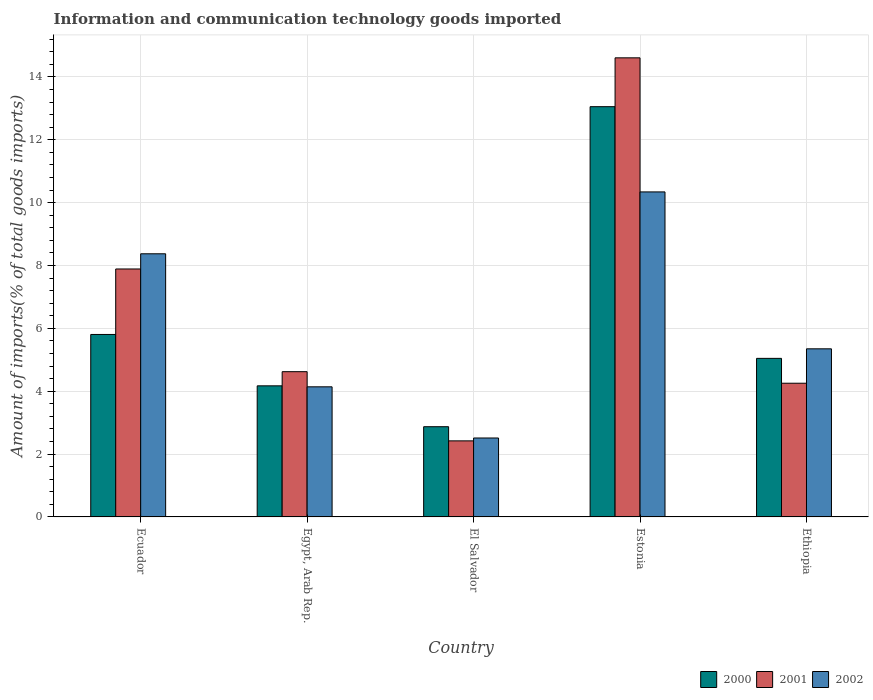How many different coloured bars are there?
Your response must be concise. 3. Are the number of bars on each tick of the X-axis equal?
Offer a very short reply. Yes. How many bars are there on the 5th tick from the left?
Your answer should be very brief. 3. How many bars are there on the 4th tick from the right?
Keep it short and to the point. 3. What is the label of the 1st group of bars from the left?
Your answer should be compact. Ecuador. In how many cases, is the number of bars for a given country not equal to the number of legend labels?
Your answer should be very brief. 0. What is the amount of goods imported in 2002 in Ethiopia?
Offer a terse response. 5.35. Across all countries, what is the maximum amount of goods imported in 2002?
Give a very brief answer. 10.34. Across all countries, what is the minimum amount of goods imported in 2001?
Offer a very short reply. 2.42. In which country was the amount of goods imported in 2000 maximum?
Offer a terse response. Estonia. In which country was the amount of goods imported in 2001 minimum?
Your response must be concise. El Salvador. What is the total amount of goods imported in 2001 in the graph?
Give a very brief answer. 33.79. What is the difference between the amount of goods imported in 2002 in Egypt, Arab Rep. and that in Ethiopia?
Your answer should be compact. -1.21. What is the difference between the amount of goods imported in 2002 in El Salvador and the amount of goods imported in 2001 in Egypt, Arab Rep.?
Your answer should be compact. -2.11. What is the average amount of goods imported in 2001 per country?
Your answer should be compact. 6.76. What is the difference between the amount of goods imported of/in 2002 and amount of goods imported of/in 2001 in Egypt, Arab Rep.?
Make the answer very short. -0.48. In how many countries, is the amount of goods imported in 2002 greater than 6.4 %?
Your answer should be compact. 2. What is the ratio of the amount of goods imported in 2000 in Ecuador to that in Egypt, Arab Rep.?
Make the answer very short. 1.39. Is the amount of goods imported in 2002 in Egypt, Arab Rep. less than that in Ethiopia?
Your answer should be compact. Yes. Is the difference between the amount of goods imported in 2002 in Estonia and Ethiopia greater than the difference between the amount of goods imported in 2001 in Estonia and Ethiopia?
Your answer should be very brief. No. What is the difference between the highest and the second highest amount of goods imported in 2001?
Provide a succinct answer. -9.99. What is the difference between the highest and the lowest amount of goods imported in 2001?
Make the answer very short. 12.19. In how many countries, is the amount of goods imported in 2002 greater than the average amount of goods imported in 2002 taken over all countries?
Make the answer very short. 2. What does the 1st bar from the left in Egypt, Arab Rep. represents?
Offer a terse response. 2000. How many bars are there?
Provide a short and direct response. 15. Are all the bars in the graph horizontal?
Provide a short and direct response. No. What is the difference between two consecutive major ticks on the Y-axis?
Provide a short and direct response. 2. Are the values on the major ticks of Y-axis written in scientific E-notation?
Make the answer very short. No. Does the graph contain any zero values?
Keep it short and to the point. No. Does the graph contain grids?
Provide a short and direct response. Yes. How many legend labels are there?
Offer a terse response. 3. How are the legend labels stacked?
Provide a succinct answer. Horizontal. What is the title of the graph?
Give a very brief answer. Information and communication technology goods imported. Does "1990" appear as one of the legend labels in the graph?
Your answer should be very brief. No. What is the label or title of the Y-axis?
Make the answer very short. Amount of imports(% of total goods imports). What is the Amount of imports(% of total goods imports) of 2000 in Ecuador?
Offer a very short reply. 5.81. What is the Amount of imports(% of total goods imports) in 2001 in Ecuador?
Provide a short and direct response. 7.89. What is the Amount of imports(% of total goods imports) of 2002 in Ecuador?
Provide a succinct answer. 8.37. What is the Amount of imports(% of total goods imports) of 2000 in Egypt, Arab Rep.?
Provide a short and direct response. 4.17. What is the Amount of imports(% of total goods imports) of 2001 in Egypt, Arab Rep.?
Make the answer very short. 4.62. What is the Amount of imports(% of total goods imports) in 2002 in Egypt, Arab Rep.?
Your answer should be compact. 4.14. What is the Amount of imports(% of total goods imports) of 2000 in El Salvador?
Make the answer very short. 2.87. What is the Amount of imports(% of total goods imports) of 2001 in El Salvador?
Keep it short and to the point. 2.42. What is the Amount of imports(% of total goods imports) of 2002 in El Salvador?
Offer a terse response. 2.51. What is the Amount of imports(% of total goods imports) in 2000 in Estonia?
Your response must be concise. 13.05. What is the Amount of imports(% of total goods imports) of 2001 in Estonia?
Your response must be concise. 14.61. What is the Amount of imports(% of total goods imports) in 2002 in Estonia?
Offer a terse response. 10.34. What is the Amount of imports(% of total goods imports) in 2000 in Ethiopia?
Your answer should be very brief. 5.05. What is the Amount of imports(% of total goods imports) in 2001 in Ethiopia?
Offer a very short reply. 4.25. What is the Amount of imports(% of total goods imports) in 2002 in Ethiopia?
Make the answer very short. 5.35. Across all countries, what is the maximum Amount of imports(% of total goods imports) in 2000?
Provide a succinct answer. 13.05. Across all countries, what is the maximum Amount of imports(% of total goods imports) in 2001?
Offer a very short reply. 14.61. Across all countries, what is the maximum Amount of imports(% of total goods imports) of 2002?
Make the answer very short. 10.34. Across all countries, what is the minimum Amount of imports(% of total goods imports) in 2000?
Keep it short and to the point. 2.87. Across all countries, what is the minimum Amount of imports(% of total goods imports) in 2001?
Keep it short and to the point. 2.42. Across all countries, what is the minimum Amount of imports(% of total goods imports) in 2002?
Make the answer very short. 2.51. What is the total Amount of imports(% of total goods imports) in 2000 in the graph?
Your response must be concise. 30.95. What is the total Amount of imports(% of total goods imports) in 2001 in the graph?
Make the answer very short. 33.79. What is the total Amount of imports(% of total goods imports) of 2002 in the graph?
Offer a terse response. 30.72. What is the difference between the Amount of imports(% of total goods imports) in 2000 in Ecuador and that in Egypt, Arab Rep.?
Your answer should be very brief. 1.63. What is the difference between the Amount of imports(% of total goods imports) of 2001 in Ecuador and that in Egypt, Arab Rep.?
Give a very brief answer. 3.27. What is the difference between the Amount of imports(% of total goods imports) in 2002 in Ecuador and that in Egypt, Arab Rep.?
Your answer should be compact. 4.23. What is the difference between the Amount of imports(% of total goods imports) in 2000 in Ecuador and that in El Salvador?
Give a very brief answer. 2.94. What is the difference between the Amount of imports(% of total goods imports) of 2001 in Ecuador and that in El Salvador?
Offer a very short reply. 5.47. What is the difference between the Amount of imports(% of total goods imports) of 2002 in Ecuador and that in El Salvador?
Provide a short and direct response. 5.86. What is the difference between the Amount of imports(% of total goods imports) of 2000 in Ecuador and that in Estonia?
Offer a terse response. -7.25. What is the difference between the Amount of imports(% of total goods imports) of 2001 in Ecuador and that in Estonia?
Offer a very short reply. -6.72. What is the difference between the Amount of imports(% of total goods imports) of 2002 in Ecuador and that in Estonia?
Your answer should be compact. -1.97. What is the difference between the Amount of imports(% of total goods imports) of 2000 in Ecuador and that in Ethiopia?
Provide a short and direct response. 0.76. What is the difference between the Amount of imports(% of total goods imports) in 2001 in Ecuador and that in Ethiopia?
Make the answer very short. 3.64. What is the difference between the Amount of imports(% of total goods imports) of 2002 in Ecuador and that in Ethiopia?
Make the answer very short. 3.02. What is the difference between the Amount of imports(% of total goods imports) of 2000 in Egypt, Arab Rep. and that in El Salvador?
Keep it short and to the point. 1.3. What is the difference between the Amount of imports(% of total goods imports) of 2001 in Egypt, Arab Rep. and that in El Salvador?
Your answer should be compact. 2.2. What is the difference between the Amount of imports(% of total goods imports) in 2002 in Egypt, Arab Rep. and that in El Salvador?
Offer a very short reply. 1.63. What is the difference between the Amount of imports(% of total goods imports) in 2000 in Egypt, Arab Rep. and that in Estonia?
Offer a very short reply. -8.88. What is the difference between the Amount of imports(% of total goods imports) of 2001 in Egypt, Arab Rep. and that in Estonia?
Provide a succinct answer. -9.99. What is the difference between the Amount of imports(% of total goods imports) in 2002 in Egypt, Arab Rep. and that in Estonia?
Offer a very short reply. -6.2. What is the difference between the Amount of imports(% of total goods imports) of 2000 in Egypt, Arab Rep. and that in Ethiopia?
Give a very brief answer. -0.87. What is the difference between the Amount of imports(% of total goods imports) in 2001 in Egypt, Arab Rep. and that in Ethiopia?
Offer a very short reply. 0.37. What is the difference between the Amount of imports(% of total goods imports) of 2002 in Egypt, Arab Rep. and that in Ethiopia?
Your answer should be very brief. -1.21. What is the difference between the Amount of imports(% of total goods imports) in 2000 in El Salvador and that in Estonia?
Your answer should be compact. -10.18. What is the difference between the Amount of imports(% of total goods imports) of 2001 in El Salvador and that in Estonia?
Make the answer very short. -12.19. What is the difference between the Amount of imports(% of total goods imports) in 2002 in El Salvador and that in Estonia?
Provide a short and direct response. -7.83. What is the difference between the Amount of imports(% of total goods imports) of 2000 in El Salvador and that in Ethiopia?
Ensure brevity in your answer.  -2.17. What is the difference between the Amount of imports(% of total goods imports) in 2001 in El Salvador and that in Ethiopia?
Offer a terse response. -1.83. What is the difference between the Amount of imports(% of total goods imports) of 2002 in El Salvador and that in Ethiopia?
Your answer should be very brief. -2.84. What is the difference between the Amount of imports(% of total goods imports) of 2000 in Estonia and that in Ethiopia?
Your answer should be compact. 8.01. What is the difference between the Amount of imports(% of total goods imports) of 2001 in Estonia and that in Ethiopia?
Give a very brief answer. 10.35. What is the difference between the Amount of imports(% of total goods imports) of 2002 in Estonia and that in Ethiopia?
Your answer should be very brief. 4.99. What is the difference between the Amount of imports(% of total goods imports) of 2000 in Ecuador and the Amount of imports(% of total goods imports) of 2001 in Egypt, Arab Rep.?
Your answer should be very brief. 1.18. What is the difference between the Amount of imports(% of total goods imports) in 2000 in Ecuador and the Amount of imports(% of total goods imports) in 2002 in Egypt, Arab Rep.?
Provide a succinct answer. 1.67. What is the difference between the Amount of imports(% of total goods imports) of 2001 in Ecuador and the Amount of imports(% of total goods imports) of 2002 in Egypt, Arab Rep.?
Your answer should be compact. 3.75. What is the difference between the Amount of imports(% of total goods imports) in 2000 in Ecuador and the Amount of imports(% of total goods imports) in 2001 in El Salvador?
Give a very brief answer. 3.39. What is the difference between the Amount of imports(% of total goods imports) in 2000 in Ecuador and the Amount of imports(% of total goods imports) in 2002 in El Salvador?
Offer a very short reply. 3.29. What is the difference between the Amount of imports(% of total goods imports) in 2001 in Ecuador and the Amount of imports(% of total goods imports) in 2002 in El Salvador?
Offer a terse response. 5.38. What is the difference between the Amount of imports(% of total goods imports) of 2000 in Ecuador and the Amount of imports(% of total goods imports) of 2001 in Estonia?
Your answer should be compact. -8.8. What is the difference between the Amount of imports(% of total goods imports) in 2000 in Ecuador and the Amount of imports(% of total goods imports) in 2002 in Estonia?
Make the answer very short. -4.54. What is the difference between the Amount of imports(% of total goods imports) in 2001 in Ecuador and the Amount of imports(% of total goods imports) in 2002 in Estonia?
Offer a terse response. -2.45. What is the difference between the Amount of imports(% of total goods imports) of 2000 in Ecuador and the Amount of imports(% of total goods imports) of 2001 in Ethiopia?
Provide a succinct answer. 1.55. What is the difference between the Amount of imports(% of total goods imports) in 2000 in Ecuador and the Amount of imports(% of total goods imports) in 2002 in Ethiopia?
Your response must be concise. 0.46. What is the difference between the Amount of imports(% of total goods imports) of 2001 in Ecuador and the Amount of imports(% of total goods imports) of 2002 in Ethiopia?
Your answer should be compact. 2.54. What is the difference between the Amount of imports(% of total goods imports) of 2000 in Egypt, Arab Rep. and the Amount of imports(% of total goods imports) of 2001 in El Salvador?
Your answer should be compact. 1.75. What is the difference between the Amount of imports(% of total goods imports) in 2000 in Egypt, Arab Rep. and the Amount of imports(% of total goods imports) in 2002 in El Salvador?
Your answer should be very brief. 1.66. What is the difference between the Amount of imports(% of total goods imports) of 2001 in Egypt, Arab Rep. and the Amount of imports(% of total goods imports) of 2002 in El Salvador?
Provide a short and direct response. 2.11. What is the difference between the Amount of imports(% of total goods imports) in 2000 in Egypt, Arab Rep. and the Amount of imports(% of total goods imports) in 2001 in Estonia?
Your answer should be compact. -10.44. What is the difference between the Amount of imports(% of total goods imports) in 2000 in Egypt, Arab Rep. and the Amount of imports(% of total goods imports) in 2002 in Estonia?
Provide a short and direct response. -6.17. What is the difference between the Amount of imports(% of total goods imports) of 2001 in Egypt, Arab Rep. and the Amount of imports(% of total goods imports) of 2002 in Estonia?
Provide a short and direct response. -5.72. What is the difference between the Amount of imports(% of total goods imports) of 2000 in Egypt, Arab Rep. and the Amount of imports(% of total goods imports) of 2001 in Ethiopia?
Provide a succinct answer. -0.08. What is the difference between the Amount of imports(% of total goods imports) in 2000 in Egypt, Arab Rep. and the Amount of imports(% of total goods imports) in 2002 in Ethiopia?
Your answer should be compact. -1.18. What is the difference between the Amount of imports(% of total goods imports) of 2001 in Egypt, Arab Rep. and the Amount of imports(% of total goods imports) of 2002 in Ethiopia?
Ensure brevity in your answer.  -0.73. What is the difference between the Amount of imports(% of total goods imports) of 2000 in El Salvador and the Amount of imports(% of total goods imports) of 2001 in Estonia?
Your answer should be very brief. -11.74. What is the difference between the Amount of imports(% of total goods imports) of 2000 in El Salvador and the Amount of imports(% of total goods imports) of 2002 in Estonia?
Make the answer very short. -7.47. What is the difference between the Amount of imports(% of total goods imports) of 2001 in El Salvador and the Amount of imports(% of total goods imports) of 2002 in Estonia?
Provide a short and direct response. -7.92. What is the difference between the Amount of imports(% of total goods imports) in 2000 in El Salvador and the Amount of imports(% of total goods imports) in 2001 in Ethiopia?
Your answer should be very brief. -1.38. What is the difference between the Amount of imports(% of total goods imports) in 2000 in El Salvador and the Amount of imports(% of total goods imports) in 2002 in Ethiopia?
Provide a succinct answer. -2.48. What is the difference between the Amount of imports(% of total goods imports) of 2001 in El Salvador and the Amount of imports(% of total goods imports) of 2002 in Ethiopia?
Ensure brevity in your answer.  -2.93. What is the difference between the Amount of imports(% of total goods imports) in 2000 in Estonia and the Amount of imports(% of total goods imports) in 2001 in Ethiopia?
Provide a succinct answer. 8.8. What is the difference between the Amount of imports(% of total goods imports) of 2000 in Estonia and the Amount of imports(% of total goods imports) of 2002 in Ethiopia?
Your response must be concise. 7.71. What is the difference between the Amount of imports(% of total goods imports) of 2001 in Estonia and the Amount of imports(% of total goods imports) of 2002 in Ethiopia?
Give a very brief answer. 9.26. What is the average Amount of imports(% of total goods imports) of 2000 per country?
Your response must be concise. 6.19. What is the average Amount of imports(% of total goods imports) of 2001 per country?
Your answer should be compact. 6.76. What is the average Amount of imports(% of total goods imports) of 2002 per country?
Provide a short and direct response. 6.14. What is the difference between the Amount of imports(% of total goods imports) in 2000 and Amount of imports(% of total goods imports) in 2001 in Ecuador?
Provide a succinct answer. -2.08. What is the difference between the Amount of imports(% of total goods imports) in 2000 and Amount of imports(% of total goods imports) in 2002 in Ecuador?
Provide a succinct answer. -2.57. What is the difference between the Amount of imports(% of total goods imports) in 2001 and Amount of imports(% of total goods imports) in 2002 in Ecuador?
Keep it short and to the point. -0.48. What is the difference between the Amount of imports(% of total goods imports) in 2000 and Amount of imports(% of total goods imports) in 2001 in Egypt, Arab Rep.?
Ensure brevity in your answer.  -0.45. What is the difference between the Amount of imports(% of total goods imports) in 2000 and Amount of imports(% of total goods imports) in 2002 in Egypt, Arab Rep.?
Offer a terse response. 0.03. What is the difference between the Amount of imports(% of total goods imports) in 2001 and Amount of imports(% of total goods imports) in 2002 in Egypt, Arab Rep.?
Your answer should be very brief. 0.48. What is the difference between the Amount of imports(% of total goods imports) of 2000 and Amount of imports(% of total goods imports) of 2001 in El Salvador?
Ensure brevity in your answer.  0.45. What is the difference between the Amount of imports(% of total goods imports) in 2000 and Amount of imports(% of total goods imports) in 2002 in El Salvador?
Offer a terse response. 0.36. What is the difference between the Amount of imports(% of total goods imports) of 2001 and Amount of imports(% of total goods imports) of 2002 in El Salvador?
Ensure brevity in your answer.  -0.09. What is the difference between the Amount of imports(% of total goods imports) in 2000 and Amount of imports(% of total goods imports) in 2001 in Estonia?
Your answer should be compact. -1.55. What is the difference between the Amount of imports(% of total goods imports) in 2000 and Amount of imports(% of total goods imports) in 2002 in Estonia?
Your answer should be very brief. 2.71. What is the difference between the Amount of imports(% of total goods imports) in 2001 and Amount of imports(% of total goods imports) in 2002 in Estonia?
Your answer should be very brief. 4.27. What is the difference between the Amount of imports(% of total goods imports) of 2000 and Amount of imports(% of total goods imports) of 2001 in Ethiopia?
Your answer should be very brief. 0.79. What is the difference between the Amount of imports(% of total goods imports) in 2000 and Amount of imports(% of total goods imports) in 2002 in Ethiopia?
Offer a very short reply. -0.3. What is the difference between the Amount of imports(% of total goods imports) in 2001 and Amount of imports(% of total goods imports) in 2002 in Ethiopia?
Offer a terse response. -1.09. What is the ratio of the Amount of imports(% of total goods imports) of 2000 in Ecuador to that in Egypt, Arab Rep.?
Your answer should be very brief. 1.39. What is the ratio of the Amount of imports(% of total goods imports) of 2001 in Ecuador to that in Egypt, Arab Rep.?
Your response must be concise. 1.71. What is the ratio of the Amount of imports(% of total goods imports) of 2002 in Ecuador to that in Egypt, Arab Rep.?
Provide a succinct answer. 2.02. What is the ratio of the Amount of imports(% of total goods imports) in 2000 in Ecuador to that in El Salvador?
Your answer should be very brief. 2.02. What is the ratio of the Amount of imports(% of total goods imports) of 2001 in Ecuador to that in El Salvador?
Offer a terse response. 3.26. What is the ratio of the Amount of imports(% of total goods imports) of 2002 in Ecuador to that in El Salvador?
Keep it short and to the point. 3.33. What is the ratio of the Amount of imports(% of total goods imports) in 2000 in Ecuador to that in Estonia?
Keep it short and to the point. 0.44. What is the ratio of the Amount of imports(% of total goods imports) of 2001 in Ecuador to that in Estonia?
Provide a short and direct response. 0.54. What is the ratio of the Amount of imports(% of total goods imports) in 2002 in Ecuador to that in Estonia?
Your response must be concise. 0.81. What is the ratio of the Amount of imports(% of total goods imports) in 2000 in Ecuador to that in Ethiopia?
Keep it short and to the point. 1.15. What is the ratio of the Amount of imports(% of total goods imports) in 2001 in Ecuador to that in Ethiopia?
Make the answer very short. 1.85. What is the ratio of the Amount of imports(% of total goods imports) in 2002 in Ecuador to that in Ethiopia?
Ensure brevity in your answer.  1.57. What is the ratio of the Amount of imports(% of total goods imports) in 2000 in Egypt, Arab Rep. to that in El Salvador?
Your answer should be very brief. 1.45. What is the ratio of the Amount of imports(% of total goods imports) in 2001 in Egypt, Arab Rep. to that in El Salvador?
Provide a succinct answer. 1.91. What is the ratio of the Amount of imports(% of total goods imports) of 2002 in Egypt, Arab Rep. to that in El Salvador?
Give a very brief answer. 1.65. What is the ratio of the Amount of imports(% of total goods imports) of 2000 in Egypt, Arab Rep. to that in Estonia?
Your response must be concise. 0.32. What is the ratio of the Amount of imports(% of total goods imports) in 2001 in Egypt, Arab Rep. to that in Estonia?
Ensure brevity in your answer.  0.32. What is the ratio of the Amount of imports(% of total goods imports) of 2002 in Egypt, Arab Rep. to that in Estonia?
Give a very brief answer. 0.4. What is the ratio of the Amount of imports(% of total goods imports) of 2000 in Egypt, Arab Rep. to that in Ethiopia?
Your answer should be compact. 0.83. What is the ratio of the Amount of imports(% of total goods imports) in 2001 in Egypt, Arab Rep. to that in Ethiopia?
Your response must be concise. 1.09. What is the ratio of the Amount of imports(% of total goods imports) of 2002 in Egypt, Arab Rep. to that in Ethiopia?
Provide a succinct answer. 0.77. What is the ratio of the Amount of imports(% of total goods imports) in 2000 in El Salvador to that in Estonia?
Offer a very short reply. 0.22. What is the ratio of the Amount of imports(% of total goods imports) of 2001 in El Salvador to that in Estonia?
Offer a very short reply. 0.17. What is the ratio of the Amount of imports(% of total goods imports) of 2002 in El Salvador to that in Estonia?
Ensure brevity in your answer.  0.24. What is the ratio of the Amount of imports(% of total goods imports) of 2000 in El Salvador to that in Ethiopia?
Offer a very short reply. 0.57. What is the ratio of the Amount of imports(% of total goods imports) of 2001 in El Salvador to that in Ethiopia?
Ensure brevity in your answer.  0.57. What is the ratio of the Amount of imports(% of total goods imports) in 2002 in El Salvador to that in Ethiopia?
Give a very brief answer. 0.47. What is the ratio of the Amount of imports(% of total goods imports) in 2000 in Estonia to that in Ethiopia?
Your answer should be very brief. 2.59. What is the ratio of the Amount of imports(% of total goods imports) of 2001 in Estonia to that in Ethiopia?
Your response must be concise. 3.43. What is the ratio of the Amount of imports(% of total goods imports) in 2002 in Estonia to that in Ethiopia?
Make the answer very short. 1.93. What is the difference between the highest and the second highest Amount of imports(% of total goods imports) in 2000?
Offer a terse response. 7.25. What is the difference between the highest and the second highest Amount of imports(% of total goods imports) of 2001?
Ensure brevity in your answer.  6.72. What is the difference between the highest and the second highest Amount of imports(% of total goods imports) of 2002?
Give a very brief answer. 1.97. What is the difference between the highest and the lowest Amount of imports(% of total goods imports) of 2000?
Give a very brief answer. 10.18. What is the difference between the highest and the lowest Amount of imports(% of total goods imports) in 2001?
Give a very brief answer. 12.19. What is the difference between the highest and the lowest Amount of imports(% of total goods imports) in 2002?
Keep it short and to the point. 7.83. 